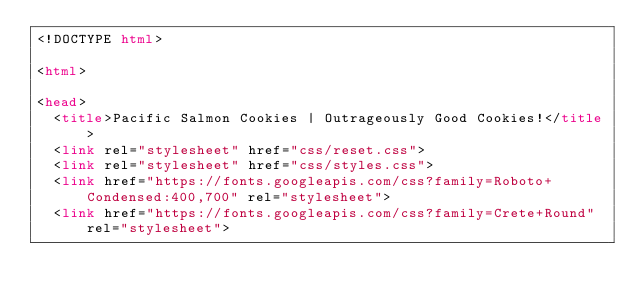Convert code to text. <code><loc_0><loc_0><loc_500><loc_500><_HTML_><!DOCTYPE html>

<html>

<head>
  <title>Pacific Salmon Cookies | Outrageously Good Cookies!</title>
  <link rel="stylesheet" href="css/reset.css">
  <link rel="stylesheet" href="css/styles.css">
  <link href="https://fonts.googleapis.com/css?family=Roboto+Condensed:400,700" rel="stylesheet">
  <link href="https://fonts.googleapis.com/css?family=Crete+Round" rel="stylesheet"></code> 